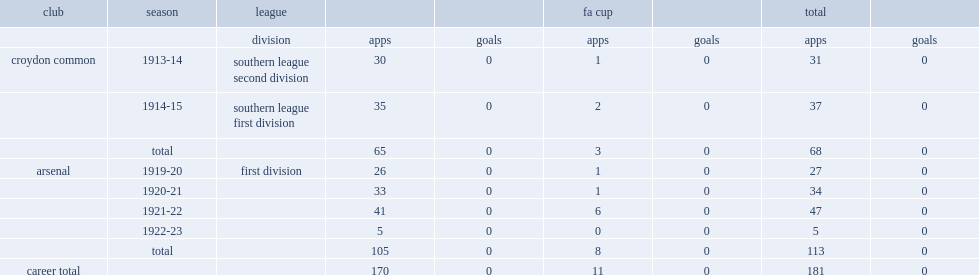How many matches did ernest williamson play for arsenal? 113.0. 